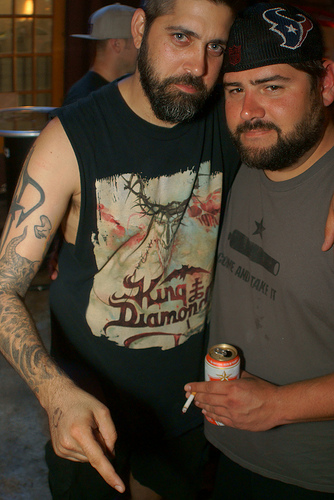<image>
Is there a man on the man? No. The man is not positioned on the man. They may be near each other, but the man is not supported by or resting on top of the man. Is there a cap on the man? No. The cap is not positioned on the man. They may be near each other, but the cap is not supported by or resting on top of the man. 